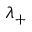Convert formula to latex. <formula><loc_0><loc_0><loc_500><loc_500>\lambda _ { + }</formula> 